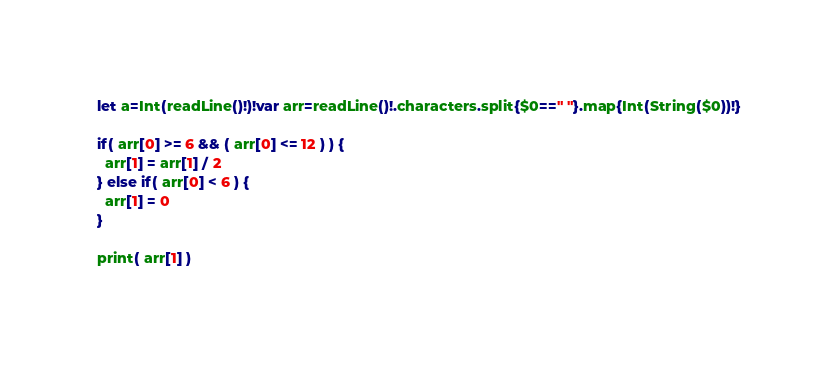<code> <loc_0><loc_0><loc_500><loc_500><_Swift_>let a=Int(readLine()!)!var arr=readLine()!.characters.split{$0==" "}.map{Int(String($0))!}

if( arr[0] >= 6 && ( arr[0] <= 12 ) ) {
  arr[1] = arr[1] / 2
} else if( arr[0] < 6 ) {
  arr[1] = 0
}
  
print( arr[1] )
  </code> 